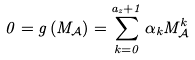<formula> <loc_0><loc_0><loc_500><loc_500>0 = g \left ( M _ { \mathcal { A } } \right ) = \sum _ { k = 0 } ^ { a _ { z } + 1 } \alpha _ { k } M _ { \mathcal { A } } ^ { k }</formula> 